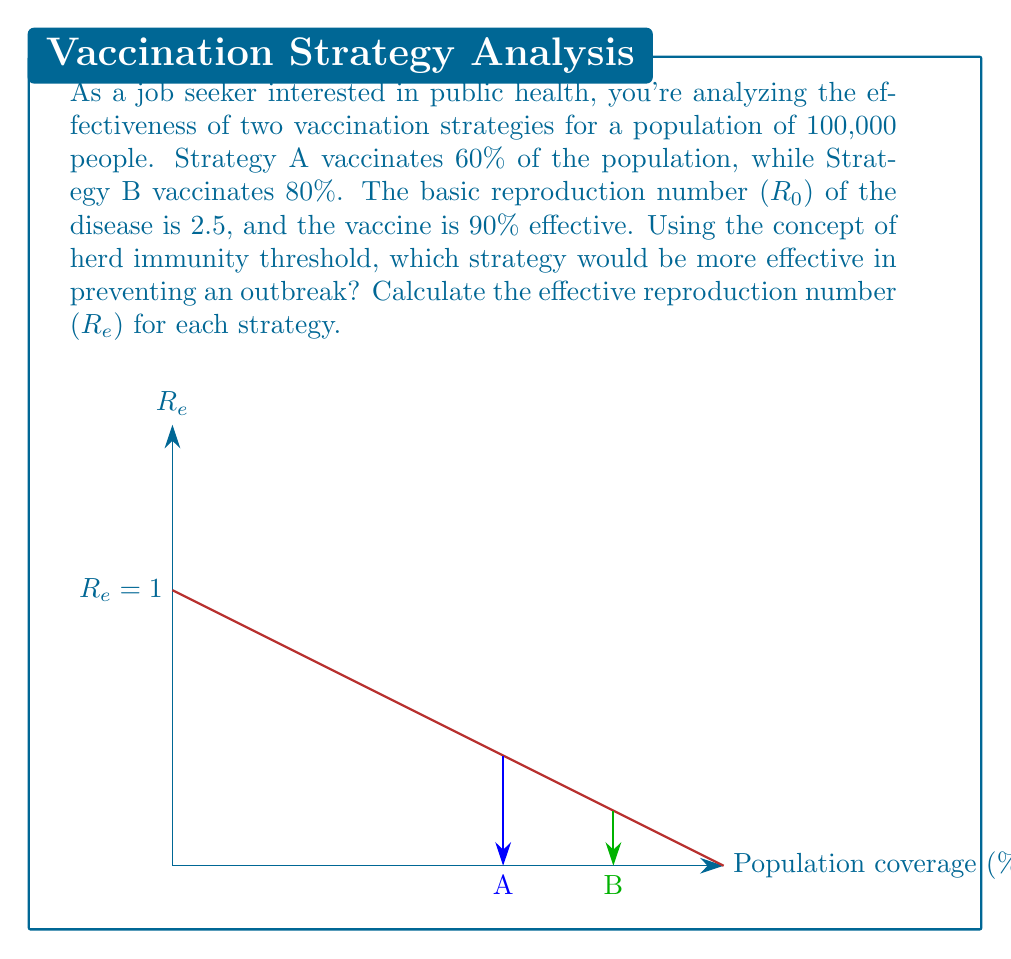Teach me how to tackle this problem. To solve this problem, we'll follow these steps:

1) First, recall the formula for the effective reproduction number:

   $$R_e = R_0 (1 - vc)$$

   Where $R_0$ is the basic reproduction number, $v$ is the vaccination coverage, and $c$ is the vaccine effectiveness.

2) For Strategy A:
   $v_A = 0.60$ (60% coverage)
   $c = 0.90$ (90% effectiveness)
   
   $$R_e^A = 2.5 (1 - 0.60 * 0.90) = 2.5 * 0.46 = 1.15$$

3) For Strategy B:
   $v_B = 0.80$ (80% coverage)
   $c = 0.90$ (90% effectiveness)
   
   $$R_e^B = 2.5 (1 - 0.80 * 0.90) = 2.5 * 0.28 = 0.70$$

4) The herd immunity threshold is reached when $R_e < 1$. This means that on average, each infected person infects less than one other person, and the outbreak will die out.

5) Strategy A results in $R_e^A = 1.15 > 1$, which means the outbreak can still spread.
   Strategy B results in $R_e^B = 0.70 < 1$, which means the outbreak will die out.

Therefore, Strategy B is more effective in preventing an outbreak as it achieves herd immunity.
Answer: Strategy B ($R_e^B = 0.70 < 1$) 